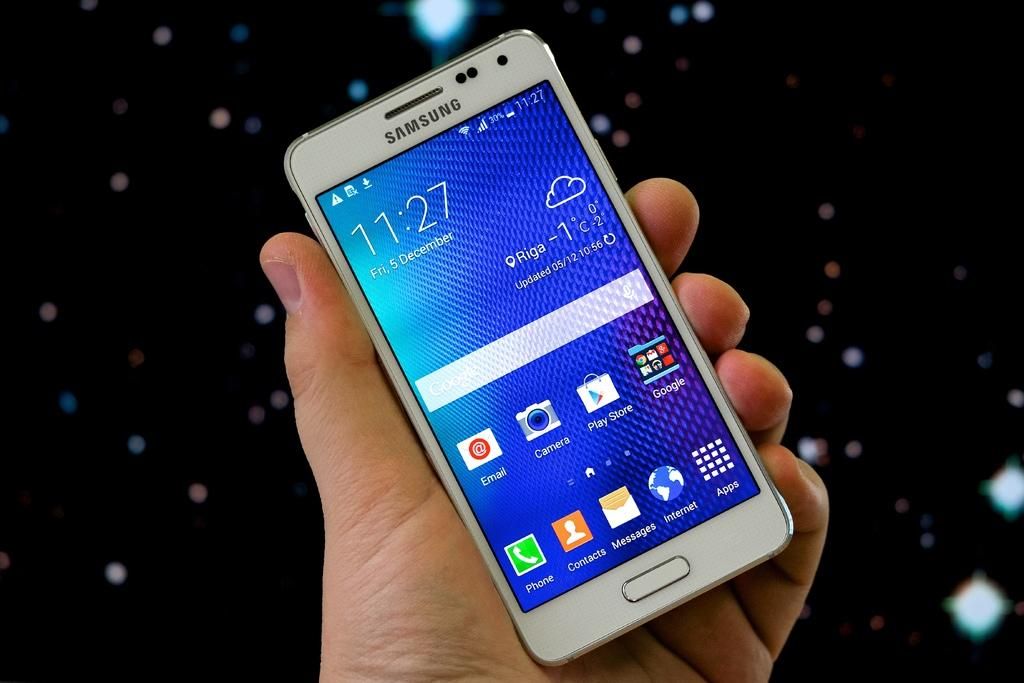<image>
Provide a brief description of the given image. The time on a Samsung phone is 11:27 at the moment. 